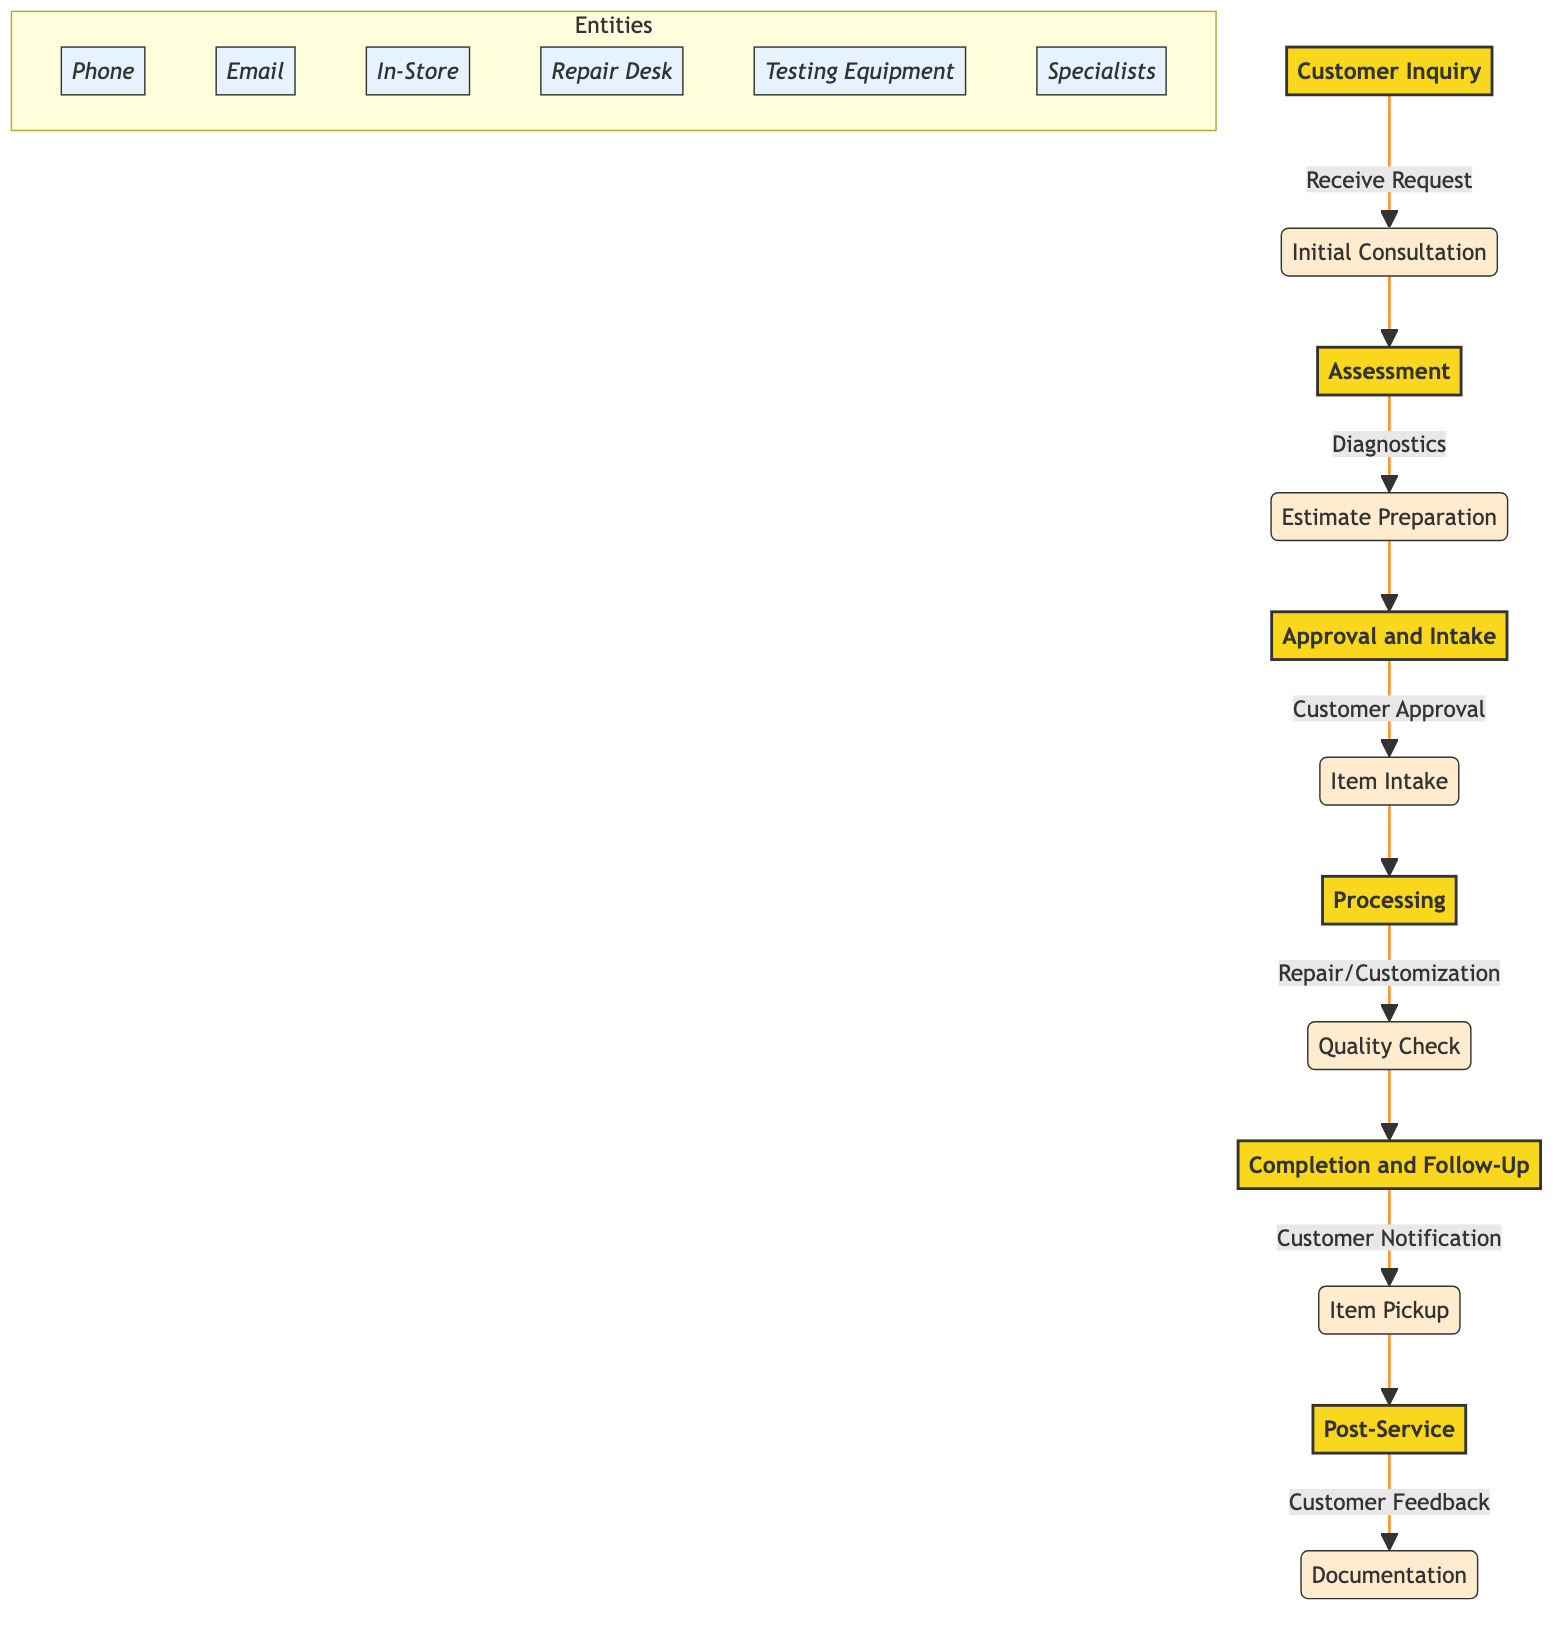What is the first stage in the diagram? The diagram indicates that the first stage is "Customer Inquiry", as it is positioned at the top without any preceding nodes.
Answer: Customer Inquiry How many steps are in the "Assessment" stage? The "Assessment" stage consists of two steps: "Diagnostics" and "Estimate Preparation". Therefore, the count of steps is two.
Answer: 2 What is the last step before the "Post-Service" stage? The last step in the pathway before reaching "Post-Service" is "Item Pickup and Confirmation". This can be seen immediately before the final stage in the flow.
Answer: Item Pickup and Confirmation Which entity is associated with "Customer Approval"? The entity associated with "Customer Approval" is "Phone, Email, In-Store", indicating the different ways a customer can provide their approval.
Answer: Phone, Email, In-Store In which stage does the "Quality Check" occur? The "Quality Check" occurs during the "Processing" stage, as visually indicated in the flow from "Repair or Customization Work" leading to "Quality Check".
Answer: Processing How many entities are listed in total within the diagram? There are six entities identified in the diagram: "Phone," "Email," "In-Store," "Repair Desk," "Testing Equipment," and "Specialists." Thus, the total is six entities.
Answer: 6 What step follows "Estimate Preparation"? The step that follows "Estimate Preparation" in the flow diagram is "Customer Approval", which is evident from the sequence of the stages.
Answer: Customer Approval Which step involves assessing the issue? The step involving assessing the issue with the vinyl record or equipment is "Diagnostics". This is the first step in the "Assessment" stage.
Answer: Diagnostics What is the primary purpose of "Customer Feedback"? The primary purpose of "Customer Feedback" is to collect feedback to improve service, which is articulated in the description of that step.
Answer: Collect feedback to improve service 